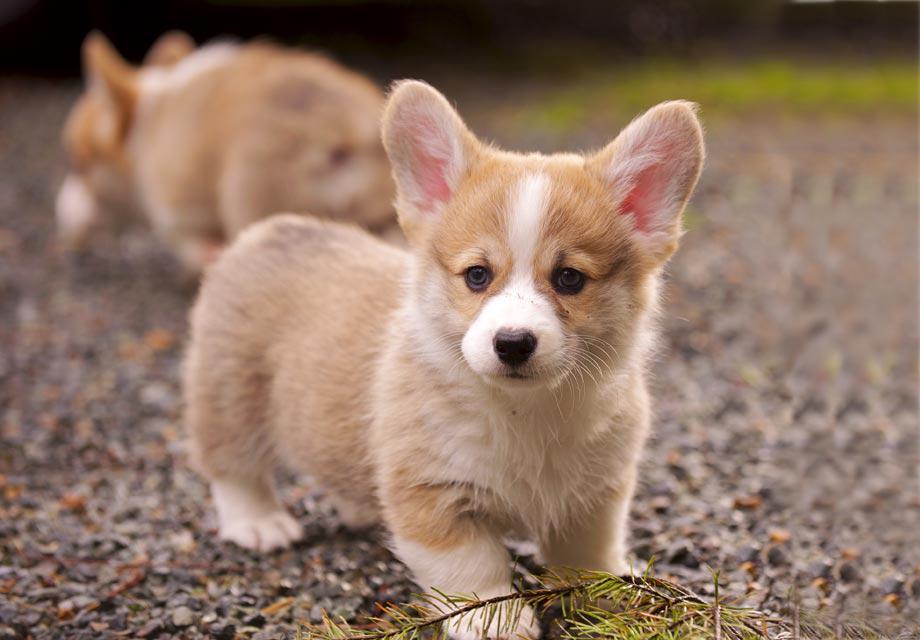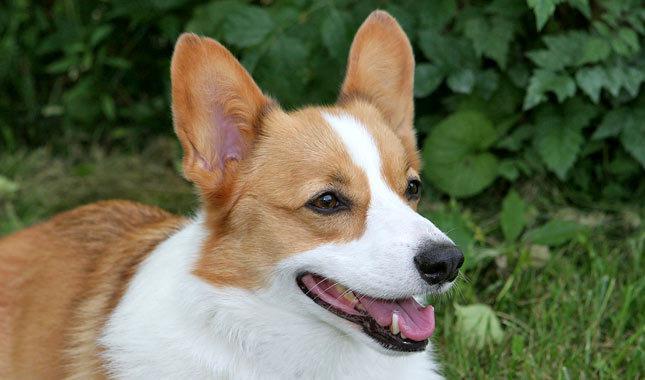The first image is the image on the left, the second image is the image on the right. Examine the images to the left and right. Is the description "At least one dog is sitting." accurate? Answer yes or no. No. The first image is the image on the left, the second image is the image on the right. Examine the images to the left and right. Is the description "The dog in the image on the left is sitting." accurate? Answer yes or no. No. The first image is the image on the left, the second image is the image on the right. For the images shown, is this caption "There is a dog in the right image on a wooden surface." true? Answer yes or no. No. 